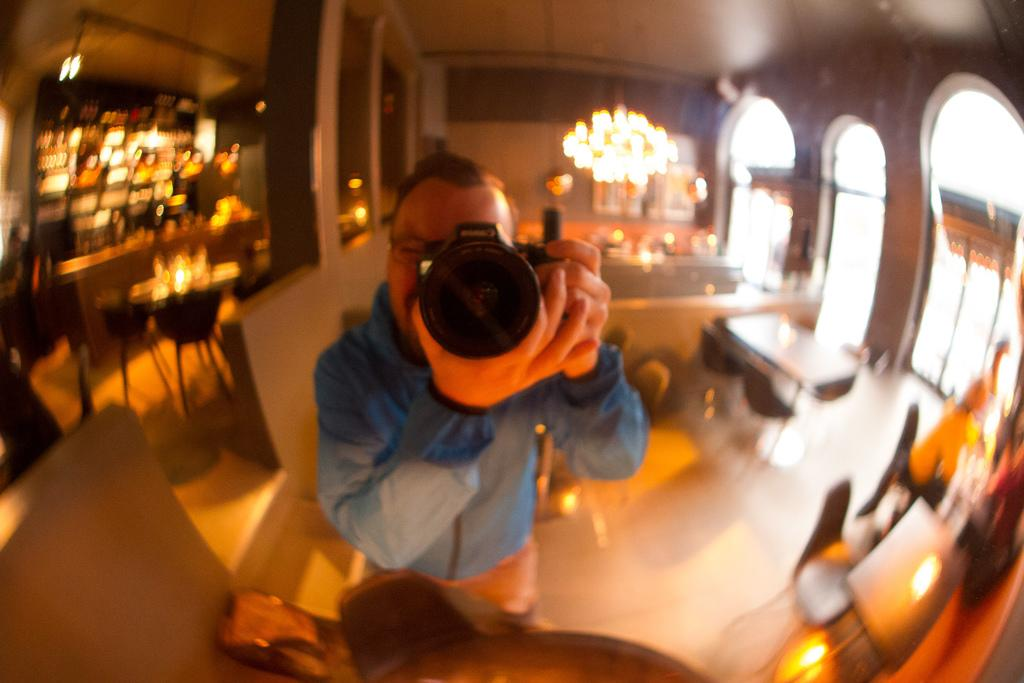What is the person in the image holding? The person in the image is holding a camera. What type of furniture can be seen in the image? There are chairs in the image. What architectural elements are present in the image? There are pillars and a wall in the image. What can be used to illuminate the area in the image? There are lights in the image. What else is present in the image besides the person and furniture? There are some objects in the image. Can you tell me what type of riddle the farmer is solving in the image? There is no farmer or riddle present in the image; it features a person holding a camera and various other elements. 